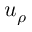Convert formula to latex. <formula><loc_0><loc_0><loc_500><loc_500>u _ { \rho }</formula> 